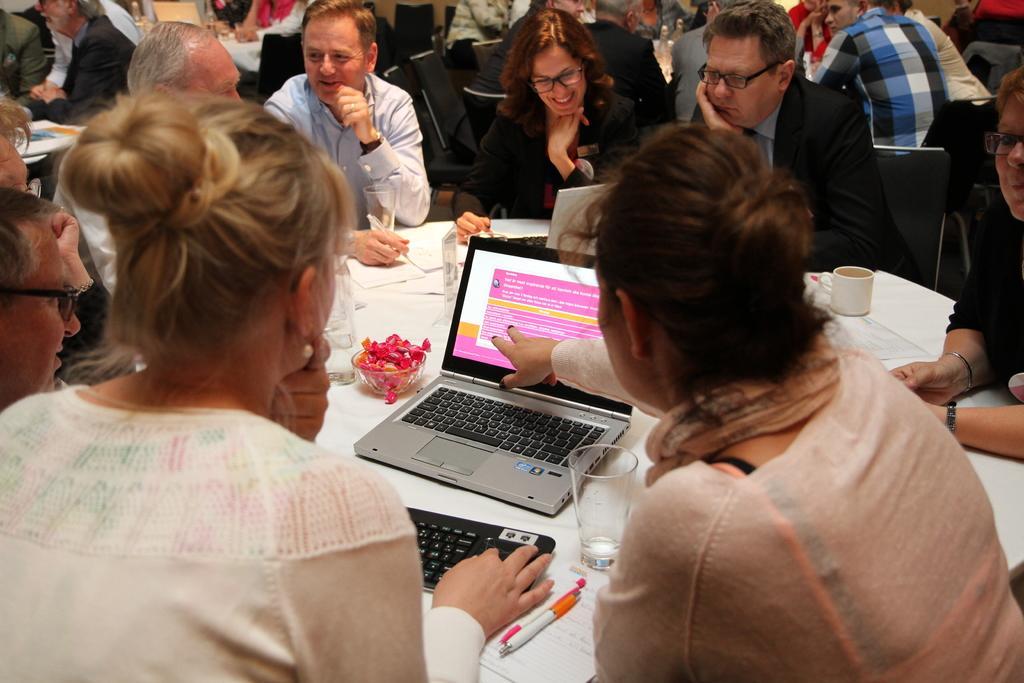In one or two sentences, can you explain what this image depicts? In the picture I can see a group of people are sitting on chairs. I can also see a table which has laptops, cups, a white color cloth covered on it and some other objects. 